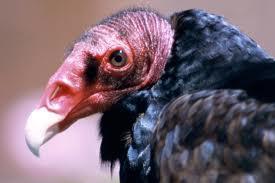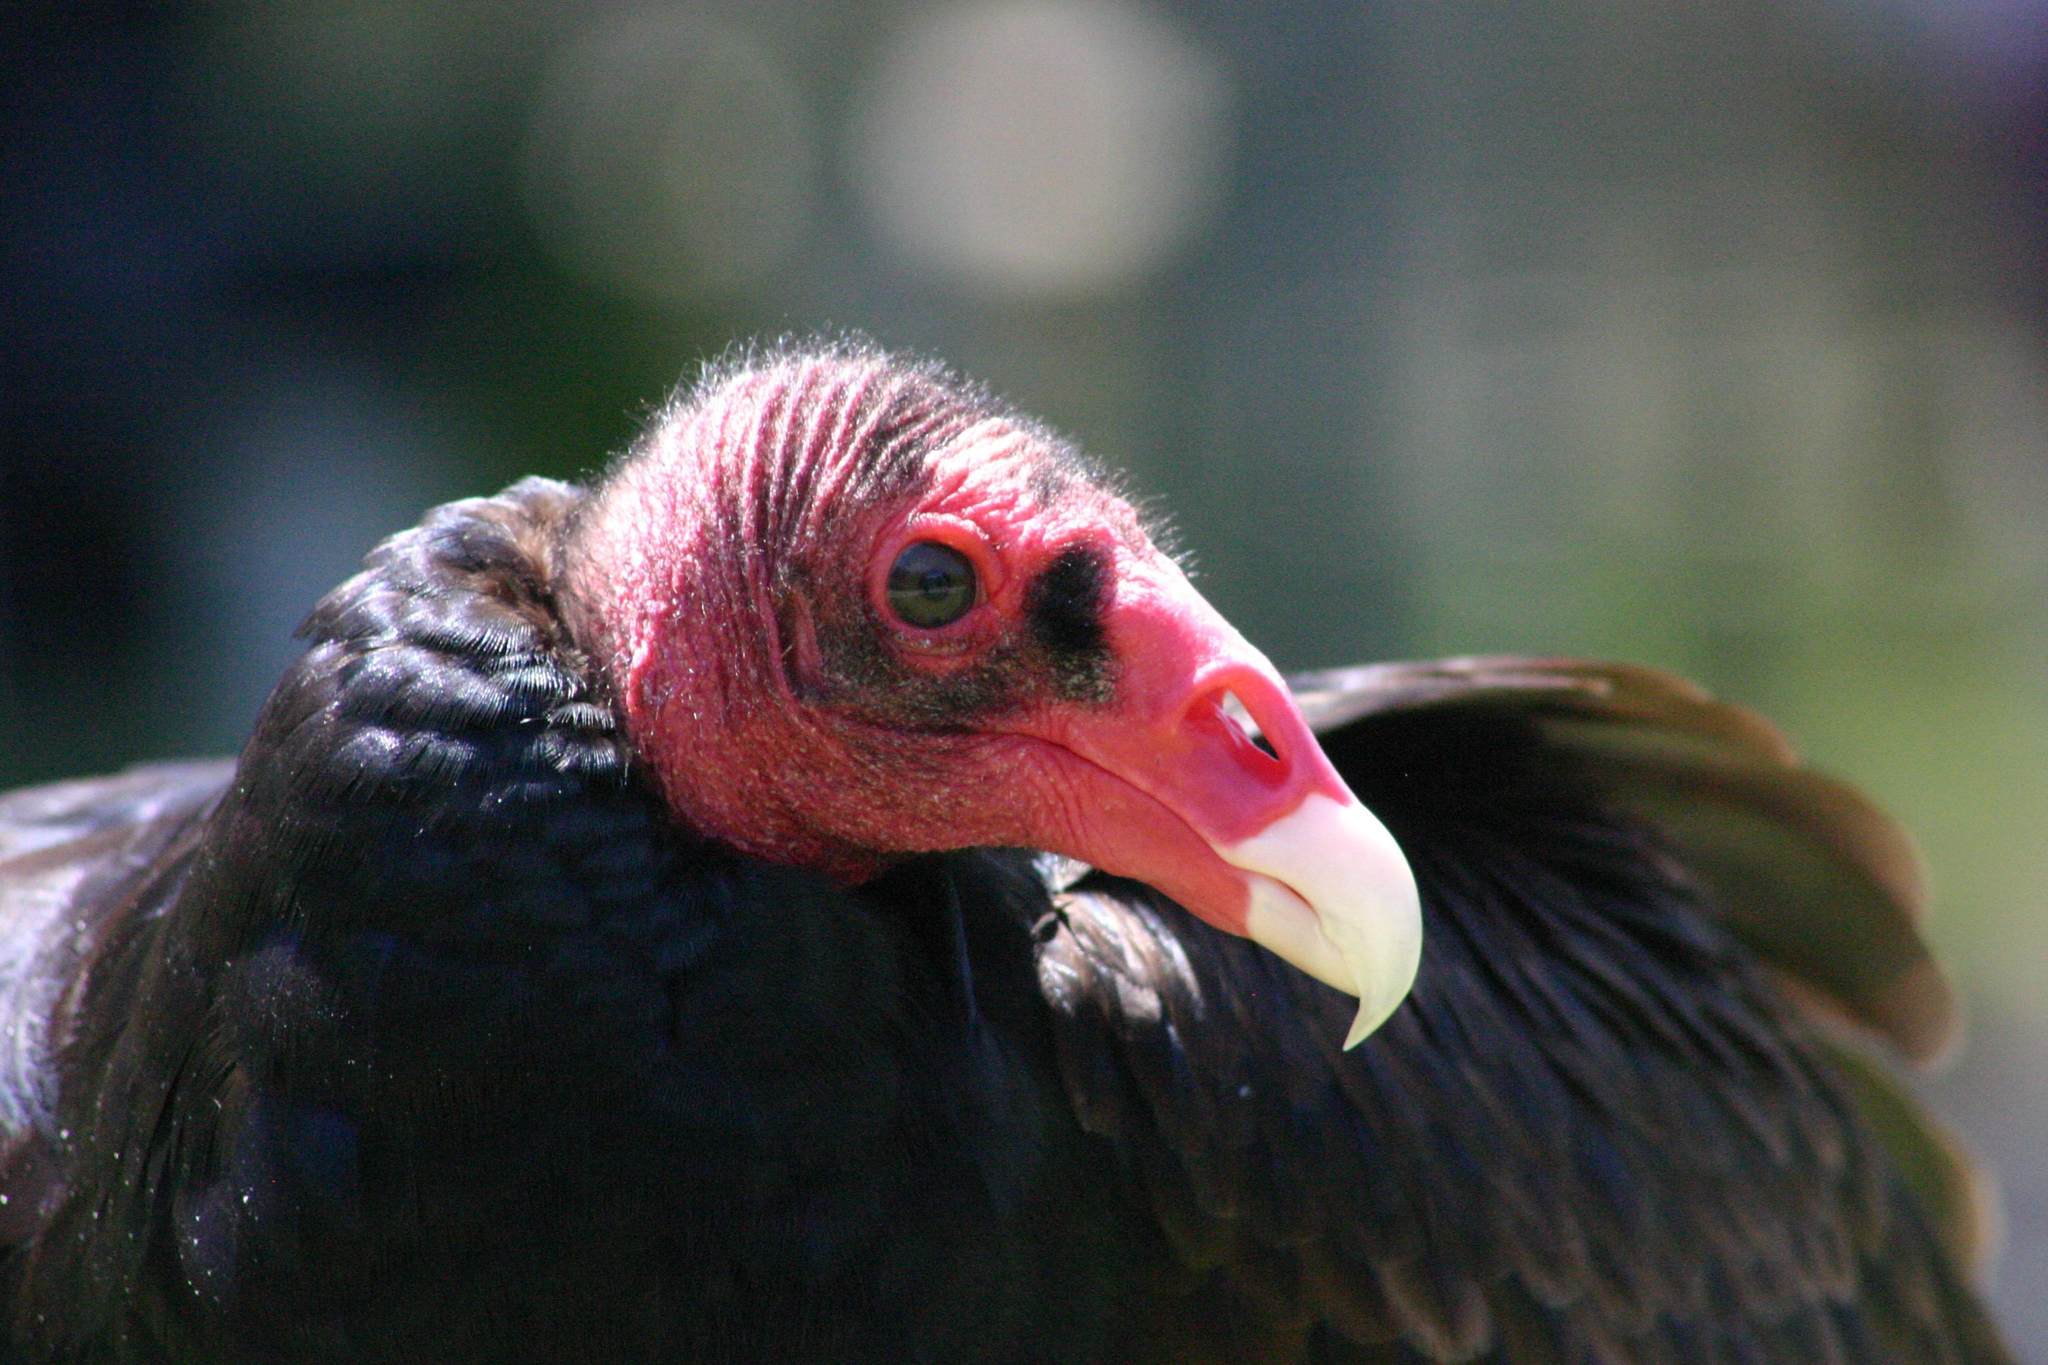The first image is the image on the left, the second image is the image on the right. Considering the images on both sides, is "Left and right images show heads of vultures facing opposite left-or-right directions." valid? Answer yes or no. Yes. The first image is the image on the left, the second image is the image on the right. For the images displayed, is the sentence "The bird in the left image is looking towards the left." factually correct? Answer yes or no. Yes. 